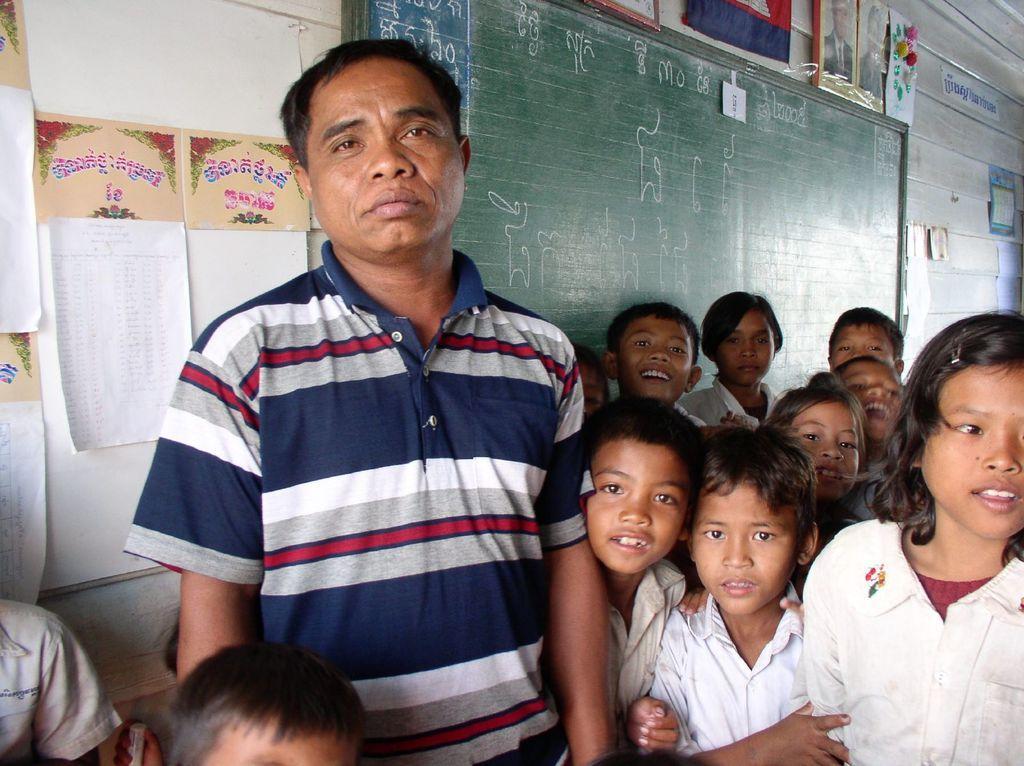Could you give a brief overview of what you see in this image? Here I can see a man and few children are standing and giving pose for the picture. At the back of these people there is a wall to which few papers, a board and photo frames are attached. 